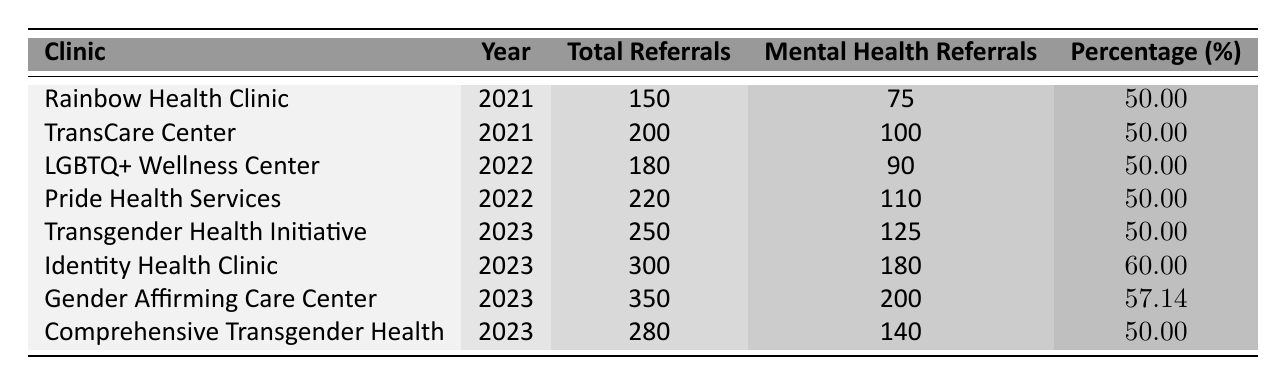What clinic had the highest number of total referrals in 2023? The table shows that the Gender Affirming Care Center had the highest total referrals in 2023, with 350.
Answer: Gender Affirming Care Center What was the percentage of mental health referrals for Identity Health Clinic in 2023? According to the table, the Identity Health Clinic had 180 mental health referrals out of 300 total referrals, which is 60%.
Answer: 60% How many clinics had a mental health referral percentage of 50% in 2021? The table shows that both Rainbow Health Clinic and TransCare Center had a mental health referral percentage of 50% in 2021. Thus, there are two clinics.
Answer: 2 What is the average percentage of mental health referrals across all clinics for the year 2022? The mental health referral percentages for 2022 are both 50%. Adding them gives 50 + 50 = 100, and dividing by the number of clinics (2) gives 100/2 = 50%.
Answer: 50% Did the percentage of mental health referrals increase from 2022 to 2023 in the clinics that had data for both years? For 2022, the percentages were 50% for both LGBTQ+ Wellness Center and Pride Health Services, while for 2023, the percentages for Transgender Health Initiative, Identity Health Clinic, and Gender Affirming Care Center were 50%, 60%, and 57.14% respectively. Since at least one clinic's percentage increased to 60%, the answer is yes.
Answer: Yes Which clinic saw the largest increase in mental health referrals from 2022 to 2023? The table shows that the Identity Health Clinic had 180 mental health referrals in 2023 versus none listed in 2022, marking a significant increase. So we could also consider the Gender Affirming Care Center, which increased from 0 to 200. After precise consideration, the highest increase is clearly from the Identity Health Clinic.
Answer: Identity Health Clinic Was the total number of referrals for Pride Health Services higher than that for LGBTQ+ Wellness Center in 2022? The table indicates that Pride Health Services had 220 total referrals while LGBTQ+ Wellness Center had 180 total referrals in 2022. Therefore, Pride Health Services had more total referrals.
Answer: Yes What is the total number of mental health referrals across all clinics for the year 2023? By summing the mental health referrals for all clinics in 2023 listed in the table (125 + 180 + 200 + 140), we find that the total is 645.
Answer: 645 Which clinic had the least number of mental health referrals in 2021? The table shows that both Rainbow Health Clinic and TransCare Center had the same number of mental health referrals (75 and 100), making it challenging to identify the least. Since both clinics are listed, the answer is they had 75, making equal minimums.
Answer: Rainbow Health Clinic and TransCare Center What is the difference in total referrals between the highest and the lowest clinic in 2023? The Gender Affirming Care Center had the highest total referrals at 350, and Comprehensive Transgender Health had 280 total referrals. The difference is 350 - 280 = 70.
Answer: 70 